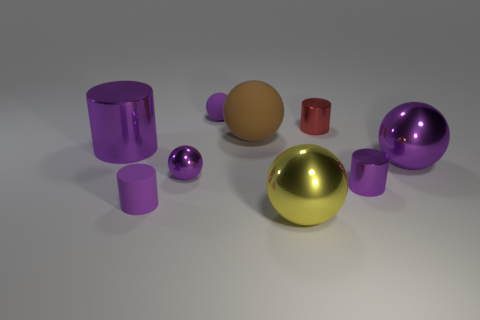The rubber thing that is on the left side of the small shiny sphere has what shape? The rubber object to the left of the small shiny sphere is cylindrically shaped, resembling a tall cup or tube with a hollow center, exhibiting a smooth, matte surface that contrasts with the reflective qualities of the surrounding spheres. 